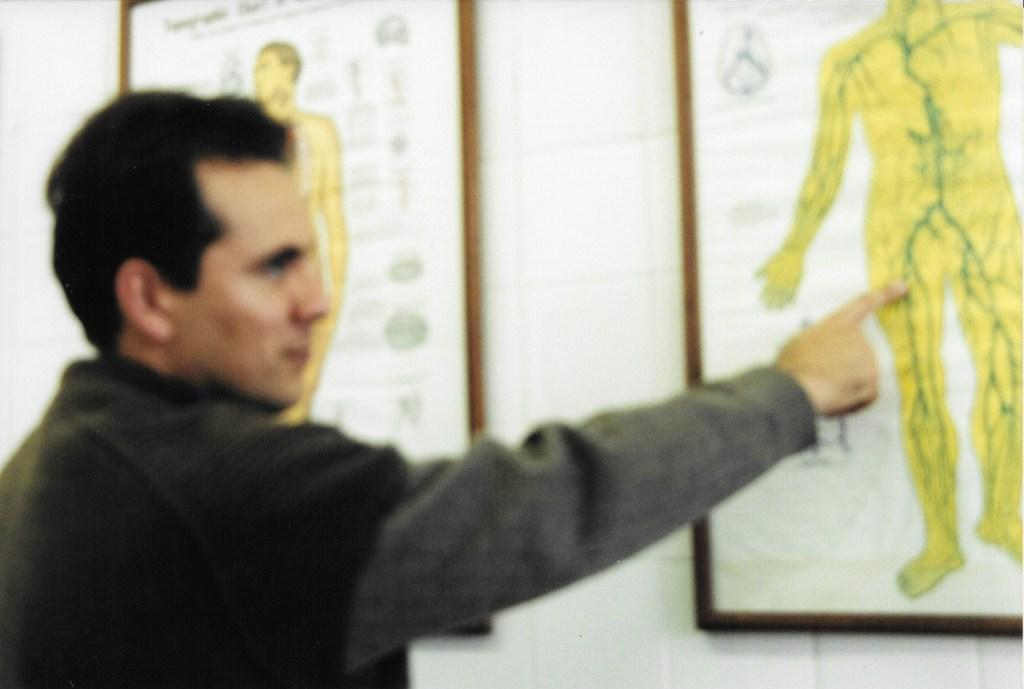What is the person in the image doing? The person is standing and pointing at a board. What can be found on the wall in the image? There are boards on the wall, and they have pictures of persons and text on them. What is the person pointing at specifically? The person is pointing at a board. How many women are crossing the bridge in the image? There is no bridge or women present in the image. What type of system is being used to display the pictures on the boards? The image does not provide information about the system used to display the pictures on the boards. 